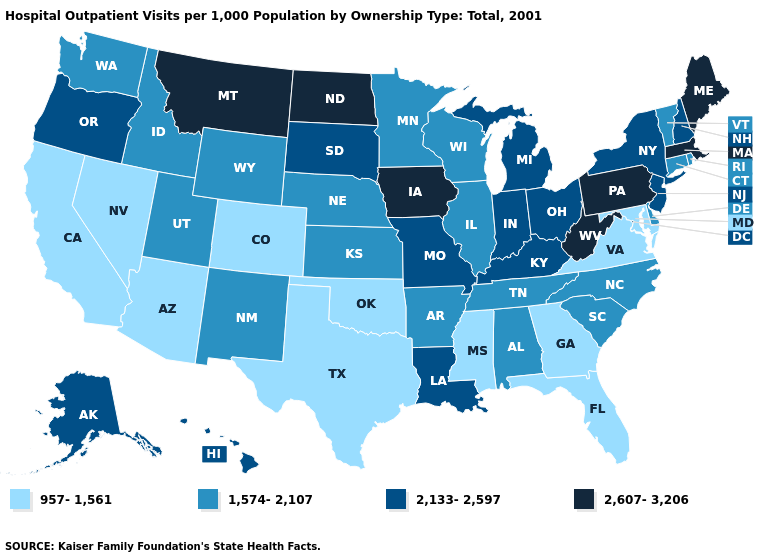Does Missouri have a lower value than Kansas?
Write a very short answer. No. What is the value of Maryland?
Answer briefly. 957-1,561. How many symbols are there in the legend?
Keep it brief. 4. How many symbols are there in the legend?
Quick response, please. 4. What is the highest value in the USA?
Be succinct. 2,607-3,206. Name the states that have a value in the range 2,607-3,206?
Give a very brief answer. Iowa, Maine, Massachusetts, Montana, North Dakota, Pennsylvania, West Virginia. Name the states that have a value in the range 2,607-3,206?
Keep it brief. Iowa, Maine, Massachusetts, Montana, North Dakota, Pennsylvania, West Virginia. Name the states that have a value in the range 1,574-2,107?
Answer briefly. Alabama, Arkansas, Connecticut, Delaware, Idaho, Illinois, Kansas, Minnesota, Nebraska, New Mexico, North Carolina, Rhode Island, South Carolina, Tennessee, Utah, Vermont, Washington, Wisconsin, Wyoming. What is the value of Oklahoma?
Be succinct. 957-1,561. Which states hav the highest value in the West?
Be succinct. Montana. What is the value of Pennsylvania?
Write a very short answer. 2,607-3,206. Is the legend a continuous bar?
Quick response, please. No. Is the legend a continuous bar?
Write a very short answer. No. Name the states that have a value in the range 2,133-2,597?
Be succinct. Alaska, Hawaii, Indiana, Kentucky, Louisiana, Michigan, Missouri, New Hampshire, New Jersey, New York, Ohio, Oregon, South Dakota. Name the states that have a value in the range 2,607-3,206?
Short answer required. Iowa, Maine, Massachusetts, Montana, North Dakota, Pennsylvania, West Virginia. 